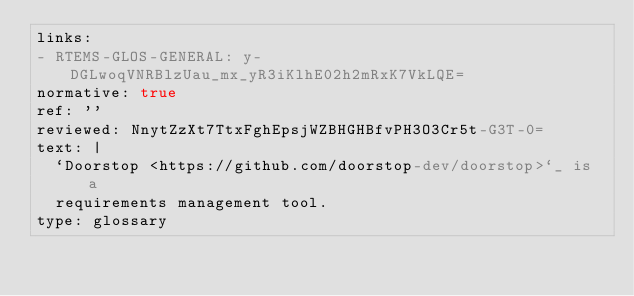Convert code to text. <code><loc_0><loc_0><loc_500><loc_500><_YAML_>links:
- RTEMS-GLOS-GENERAL: y-DGLwoqVNRBlzUau_mx_yR3iKlhE02h2mRxK7VkLQE=
normative: true
ref: ''
reviewed: NnytZzXt7TtxFghEpsjWZBHGHBfvPH3O3Cr5t-G3T-0=
text: |
  `Doorstop <https://github.com/doorstop-dev/doorstop>`_ is a
  requirements management tool.
type: glossary
</code> 